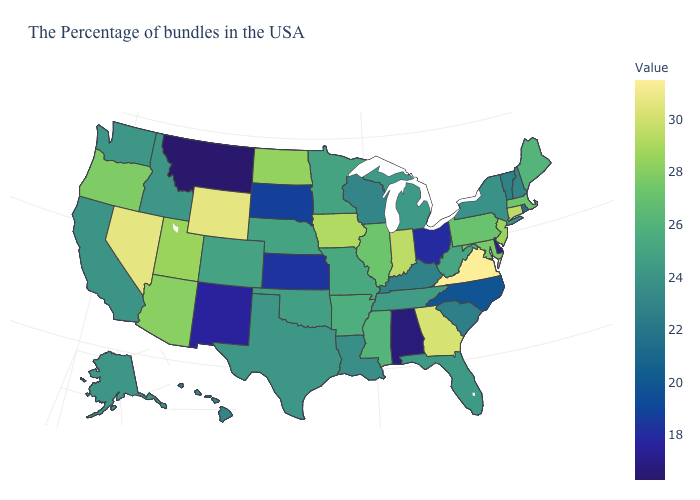Does California have a higher value than Virginia?
Short answer required. No. Among the states that border Montana , does Wyoming have the highest value?
Quick response, please. Yes. Which states have the lowest value in the USA?
Be succinct. Montana. Which states have the lowest value in the USA?
Keep it brief. Montana. Is the legend a continuous bar?
Short answer required. Yes. 